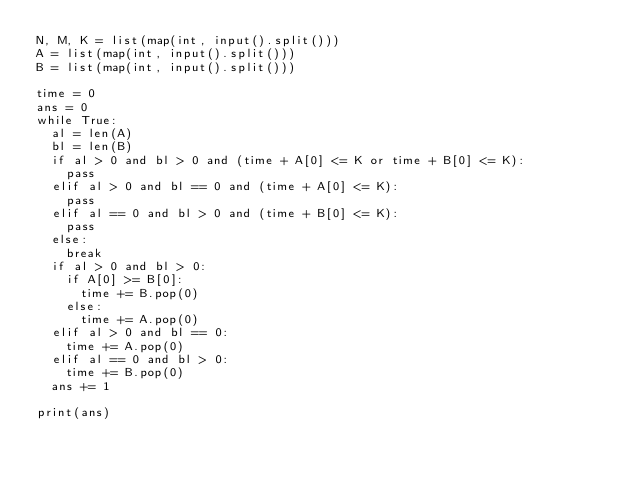<code> <loc_0><loc_0><loc_500><loc_500><_Python_>N, M, K = list(map(int, input().split()))
A = list(map(int, input().split()))
B = list(map(int, input().split()))

time = 0
ans = 0
while True:
  al = len(A)
  bl = len(B)
  if al > 0 and bl > 0 and (time + A[0] <= K or time + B[0] <= K):
    pass
  elif al > 0 and bl == 0 and (time + A[0] <= K):
    pass
  elif al == 0 and bl > 0 and (time + B[0] <= K):
    pass
  else:
    break
  if al > 0 and bl > 0:
    if A[0] >= B[0]:
      time += B.pop(0)
    else:
      time += A.pop(0)
  elif al > 0 and bl == 0:
    time += A.pop(0)
  elif al == 0 and bl > 0:
    time += B.pop(0)
  ans += 1

print(ans)</code> 